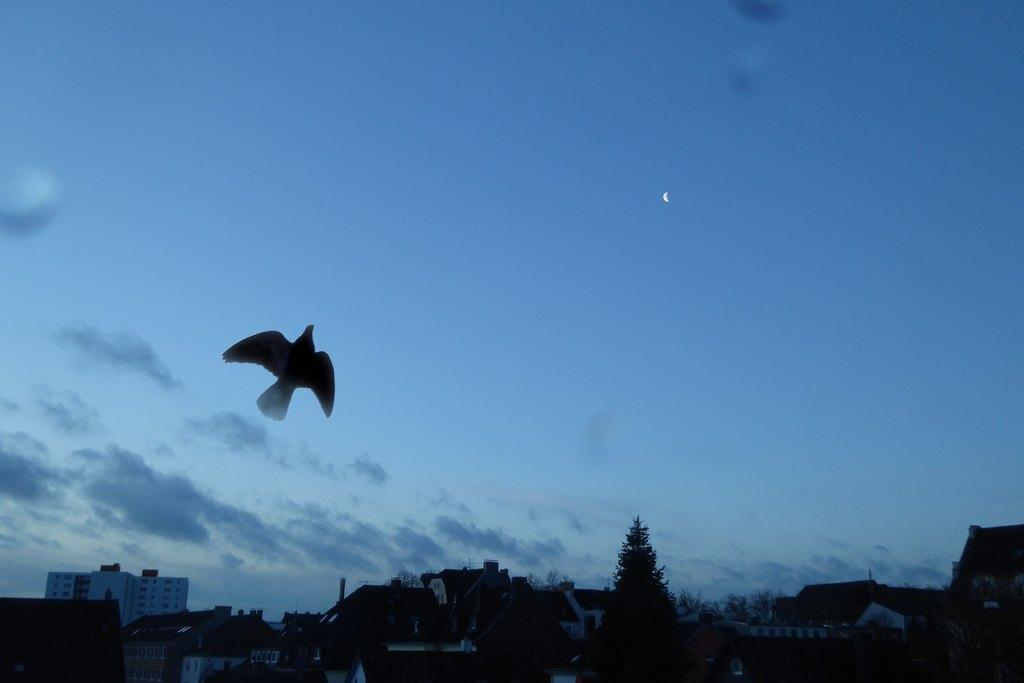What type of animal can be seen in the image? There is a bird in the image. What is visible in the background of the image? There are trees and clouds in the sky in the background of the image. What type of structures are present in the image? There are houses in the image. What type of crack is visible on the bird's beak in the image? There is no crack visible on the bird's beak in the image. What team is responsible for maintaining the houses in the image? There is no information about a team responsible for maintaining the houses in the image. 